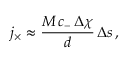Convert formula to latex. <formula><loc_0><loc_0><loc_500><loc_500>j _ { \times } \approx \frac { M \, c _ { - } \, \Delta \chi } { d } \, \Delta s \, ,</formula> 